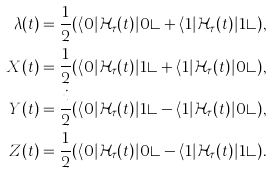<formula> <loc_0><loc_0><loc_500><loc_500>\lambda ( t ) = \frac { 1 } { 2 } ( \langle 0 | \mathcal { H } _ { \tau } ( t ) | 0 \rangle + \langle 1 | \mathcal { H } _ { \tau } ( t ) | 1 \rangle ) , \\ X ( t ) = \frac { 1 } { 2 } ( \langle 0 | \mathcal { H } _ { \tau } ( t ) | 1 \rangle + \langle 1 | \mathcal { H } _ { \tau } ( t ) | 0 \rangle ) , \\ Y ( t ) = \frac { i } { 2 } ( \langle 0 | \mathcal { H } _ { \tau } ( t ) | 1 \rangle - \langle 1 | \mathcal { H } _ { \tau } ( t ) | 0 \rangle ) , \\ Z ( t ) = \frac { 1 } { 2 } ( \langle 0 | \mathcal { H } _ { \tau } ( t ) | 0 \rangle - \langle 1 | \mathcal { H } _ { \tau } ( t ) | 1 \rangle ) .</formula> 